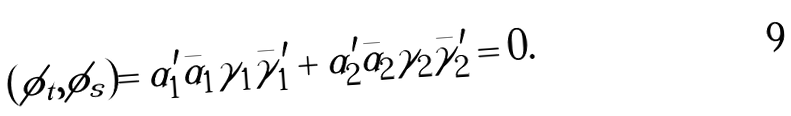<formula> <loc_0><loc_0><loc_500><loc_500>& ( \phi _ { t } , \phi _ { s } ) = \alpha ^ { \prime } _ { 1 } \bar { \alpha } _ { 1 } \gamma _ { 1 } \bar { \gamma } ^ { \prime } _ { 1 } + \alpha ^ { \prime } _ { 2 } \bar { \alpha } _ { 2 } \gamma _ { 2 } \bar { \gamma } ^ { \prime } _ { 2 } = 0 .</formula> 